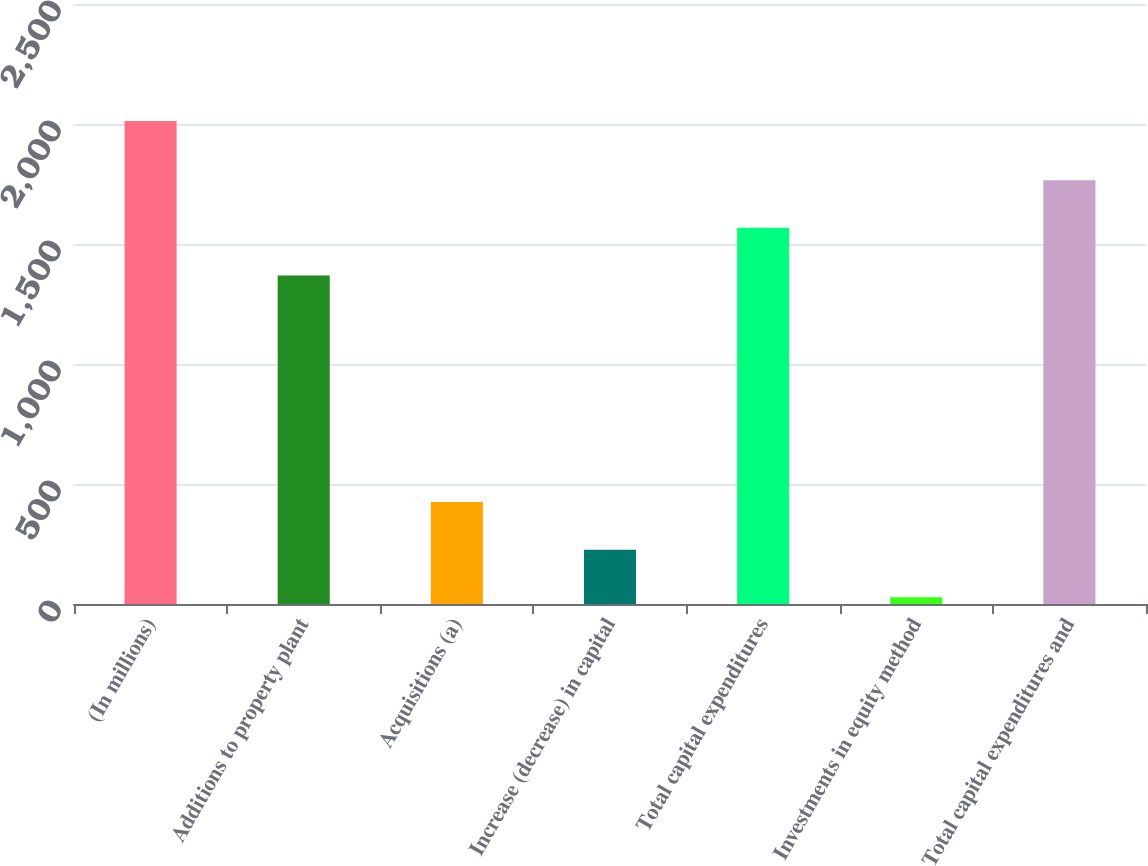<chart> <loc_0><loc_0><loc_500><loc_500><bar_chart><fcel>(In millions)<fcel>Additions to property plant<fcel>Acquisitions (a)<fcel>Increase (decrease) in capital<fcel>Total capital expenditures<fcel>Investments in equity method<fcel>Total capital expenditures and<nl><fcel>2012<fcel>1369<fcel>424.8<fcel>226.4<fcel>1567.4<fcel>28<fcel>1765.8<nl></chart> 